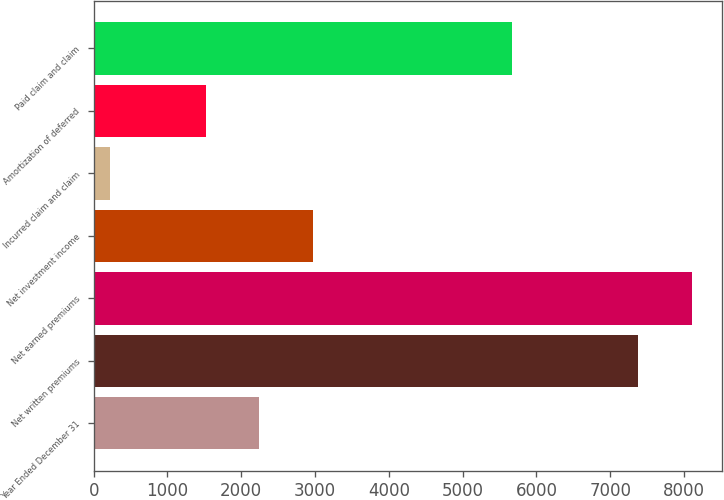Convert chart to OTSL. <chart><loc_0><loc_0><loc_500><loc_500><bar_chart><fcel>Year Ended December 31<fcel>Net written premiums<fcel>Net earned premiums<fcel>Net investment income<fcel>Incurred claim and claim<fcel>Amortization of deferred<fcel>Paid claim and claim<nl><fcel>2246.1<fcel>7382<fcel>8108.1<fcel>2972.2<fcel>220<fcel>1520<fcel>5663.1<nl></chart> 